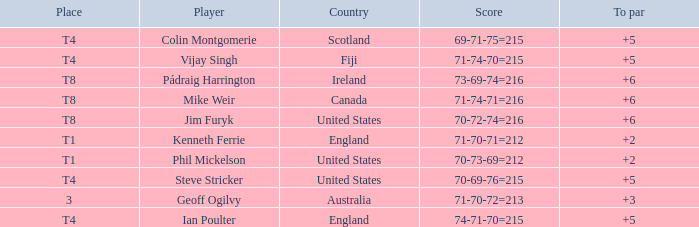Who had a score of 70-73-69=212? Phil Mickelson. Parse the full table. {'header': ['Place', 'Player', 'Country', 'Score', 'To par'], 'rows': [['T4', 'Colin Montgomerie', 'Scotland', '69-71-75=215', '+5'], ['T4', 'Vijay Singh', 'Fiji', '71-74-70=215', '+5'], ['T8', 'Pádraig Harrington', 'Ireland', '73-69-74=216', '+6'], ['T8', 'Mike Weir', 'Canada', '71-74-71=216', '+6'], ['T8', 'Jim Furyk', 'United States', '70-72-74=216', '+6'], ['T1', 'Kenneth Ferrie', 'England', '71-70-71=212', '+2'], ['T1', 'Phil Mickelson', 'United States', '70-73-69=212', '+2'], ['T4', 'Steve Stricker', 'United States', '70-69-76=215', '+5'], ['3', 'Geoff Ogilvy', 'Australia', '71-70-72=213', '+3'], ['T4', 'Ian Poulter', 'England', '74-71-70=215', '+5']]} 